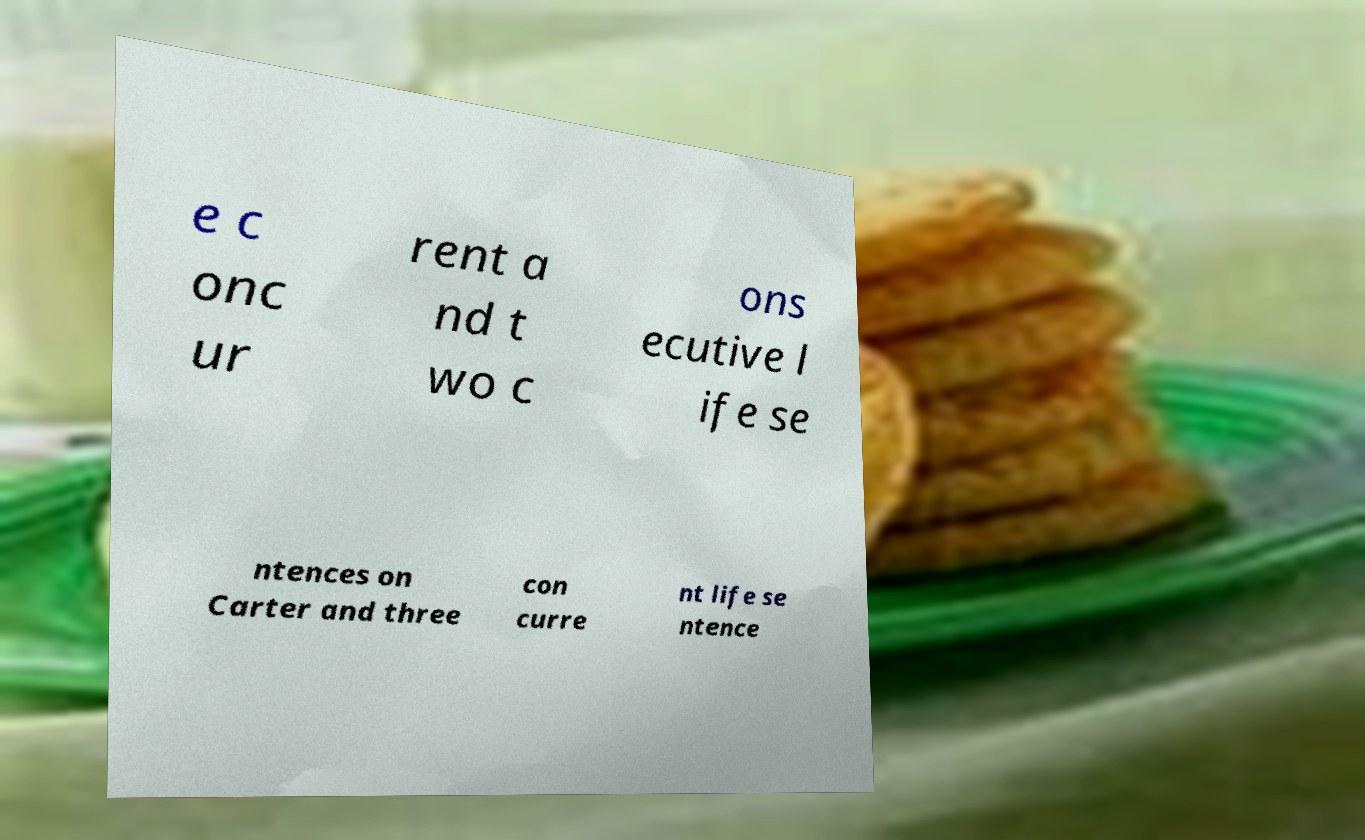For documentation purposes, I need the text within this image transcribed. Could you provide that? e c onc ur rent a nd t wo c ons ecutive l ife se ntences on Carter and three con curre nt life se ntence 